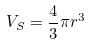<formula> <loc_0><loc_0><loc_500><loc_500>V _ { S } = \frac { 4 } { 3 } \pi r ^ { 3 }</formula> 